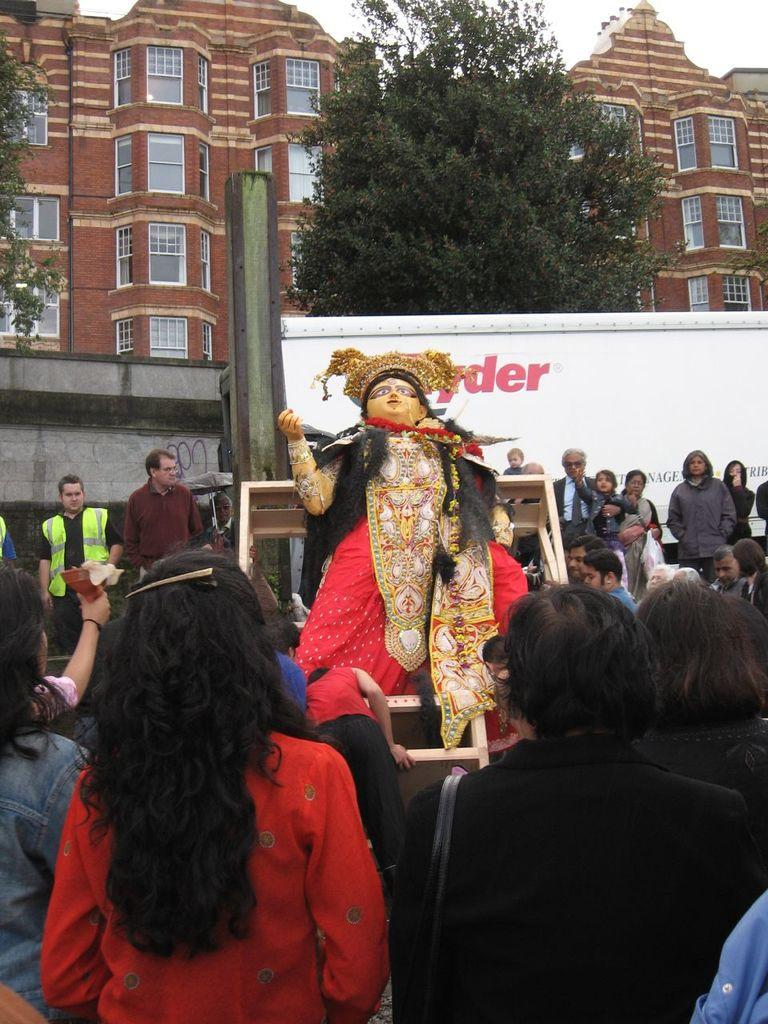What is the main subject of the image? There is a statue on a dais in the image. What can be seen around the statue? There are persons standing around the statue. What can be seen in the distance in the image? There are buildings, trees, and the sky visible in the background of the image. Where is the nearest cattle farm to the statue in the image? There is no information about cattle farms or their locations in the image. 